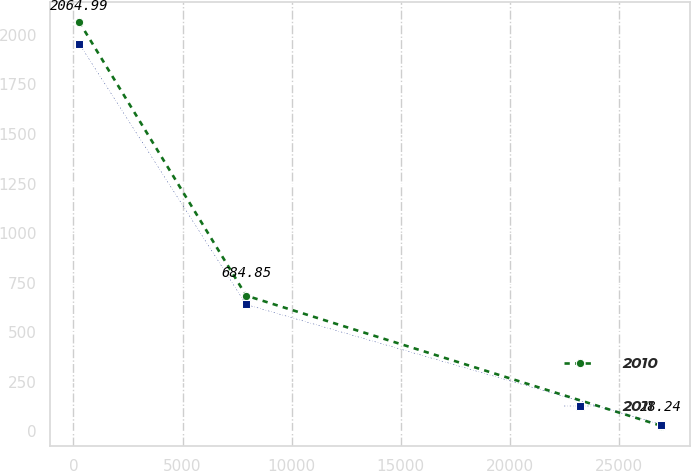Convert chart. <chart><loc_0><loc_0><loc_500><loc_500><line_chart><ecel><fcel>2010<fcel>2011<nl><fcel>264.35<fcel>2064.99<fcel>1955.27<nl><fcel>7914.22<fcel>684.85<fcel>640.15<nl><fcel>26939.7<fcel>28.24<fcel>34.39<nl></chart> 